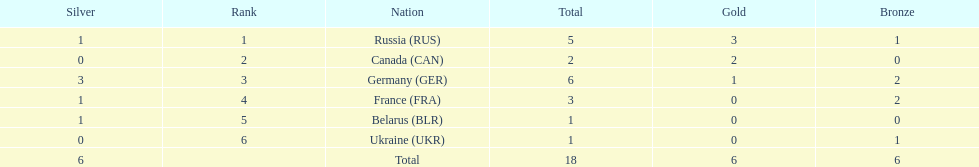Who had a larger total medal count, france or canada? France. 